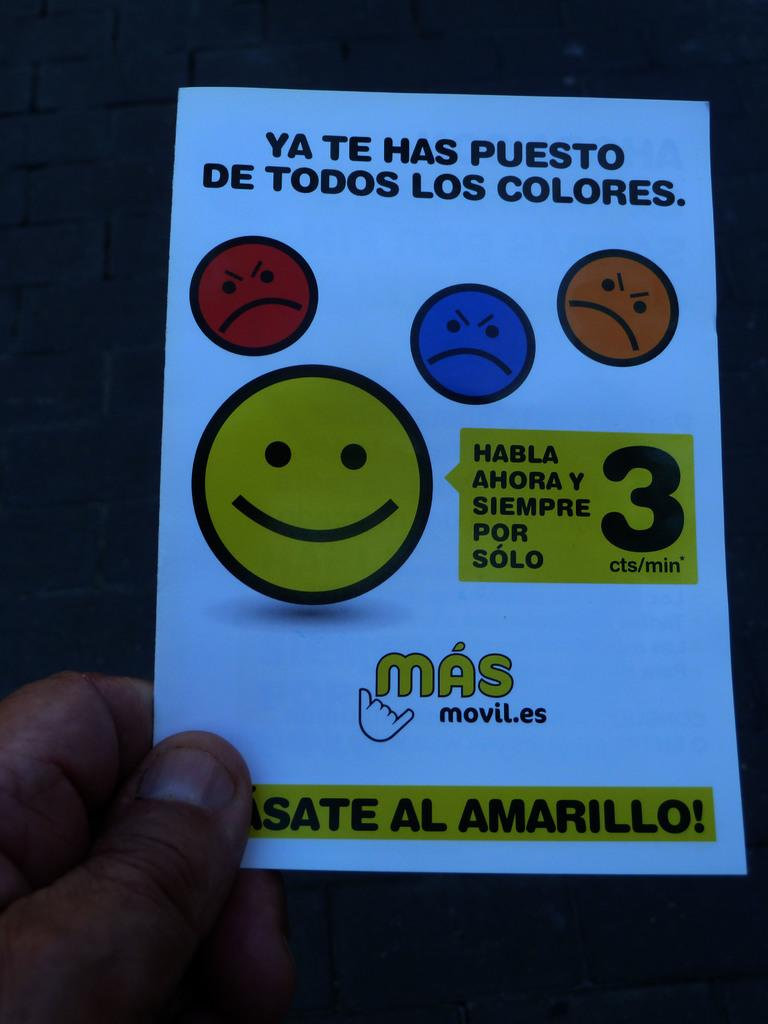What is being held by the person's hand in the foreground of the image? There is a person's hand holding a paper in the foreground of the image. Can you describe the background of the image? The background of the image is not clear. What type of bridge can be seen in the background of the image? There is no bridge visible in the image, as the background is not clear according to the provided facts. 